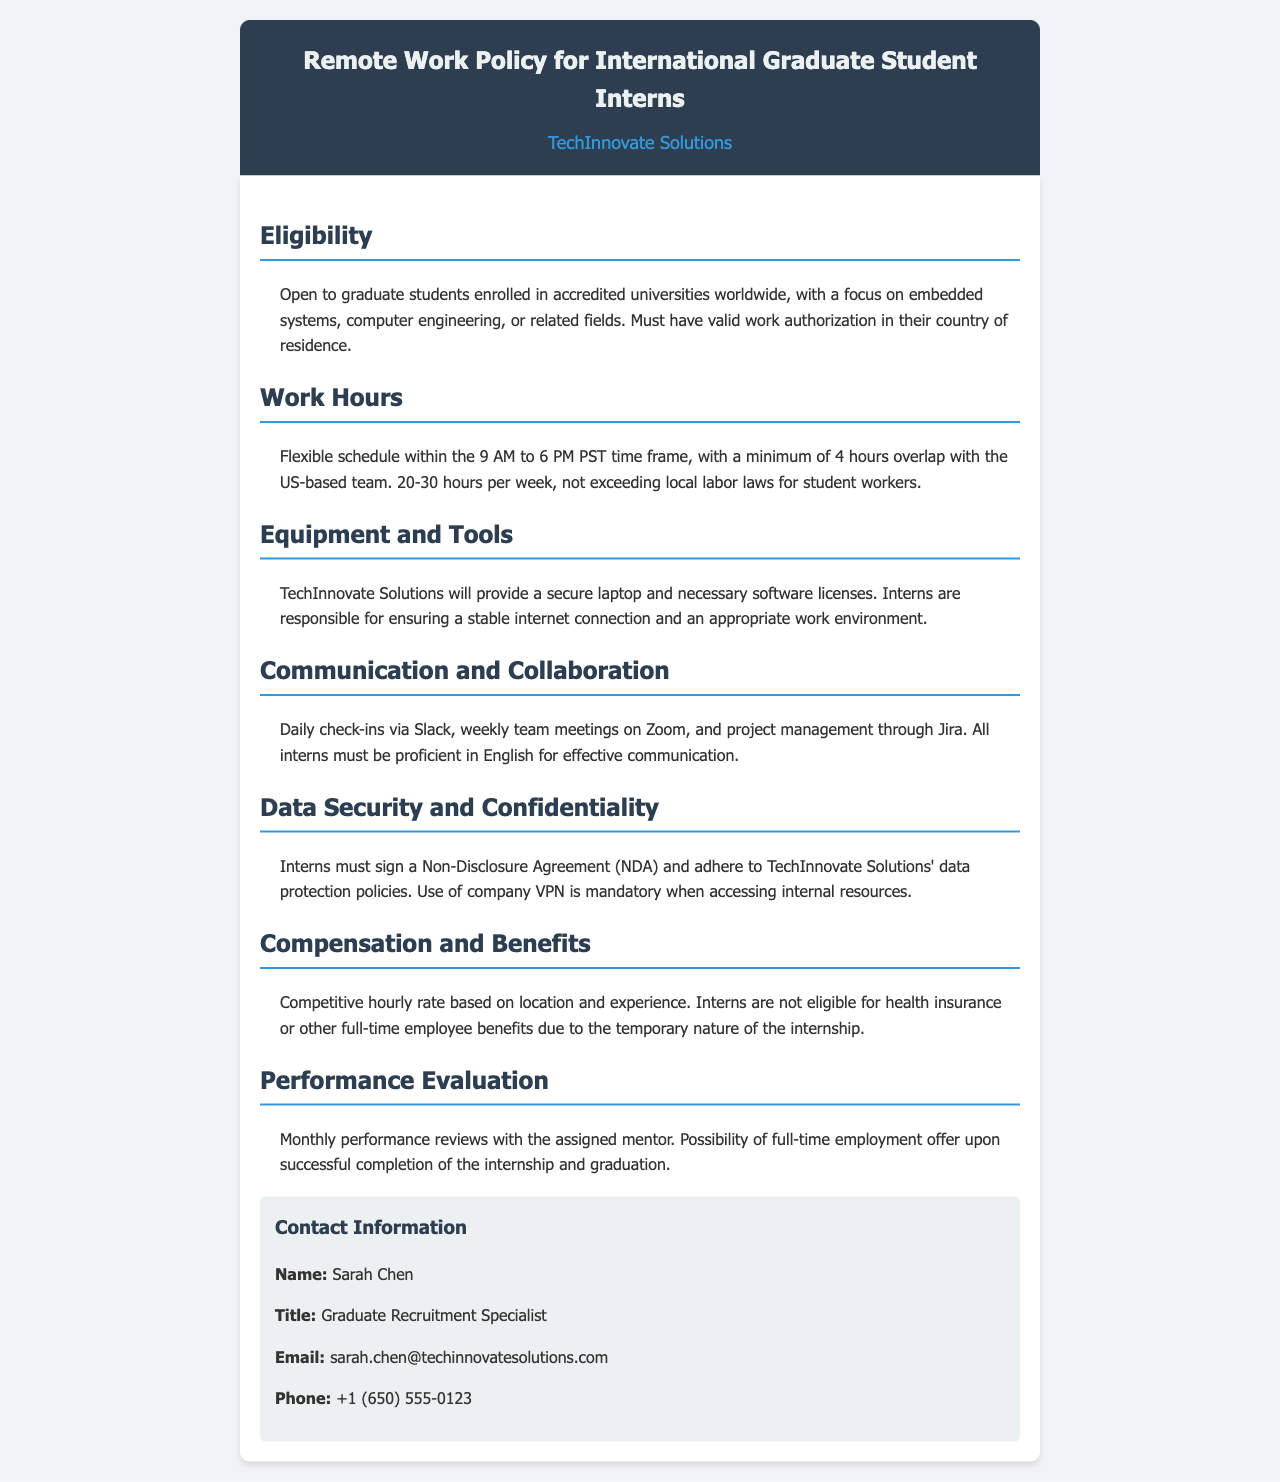What is the minimum hourly work requirement for interns? The document states that interns must work between 20-30 hours per week, not exceeding local labor laws.
Answer: 20-30 hours Who is the contact person for inquiries? The document lists Sarah Chen as the contact person for the remote work policy.
Answer: Sarah Chen What is the time frame mentioned for flexible working hours? The policy specifies that work hours should be within the 9 AM to 6 PM PST time frame.
Answer: 9 AM to 6 PM PST What must interns sign regarding confidentiality? Interns are required to sign a Non-Disclosure Agreement as part of the data security measures outlined.
Answer: Non-Disclosure Agreement What is the main communication tool used for daily check-ins? The document indicates that Slack is used for daily check-ins among interns and the team.
Answer: Slack What is the requirement for interns regarding their internet connection? Interns are responsible for ensuring a stable internet connection to facilitate remote work.
Answer: Stable internet connection How often are performance reviews conducted? The document states that monthly performance reviews are held with assigned mentors.
Answer: Monthly Are interns eligible for health insurance benefits? The document clarifies that interns are not eligible for health insurance due to the temporary nature of the internship.
Answer: No 